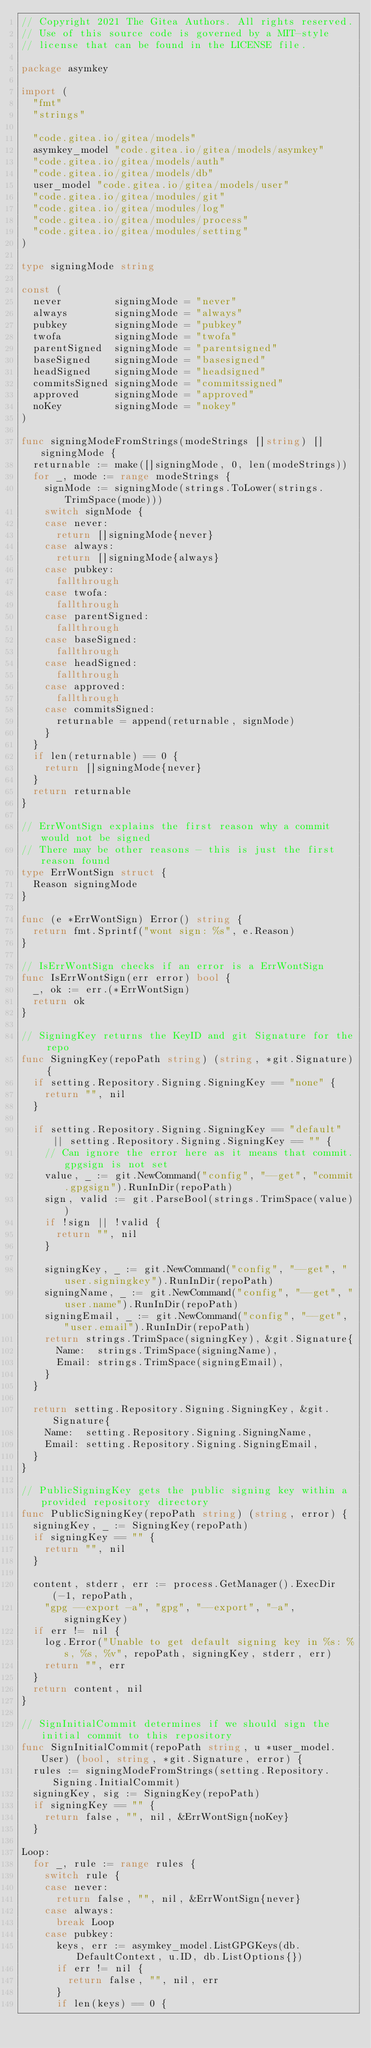<code> <loc_0><loc_0><loc_500><loc_500><_Go_>// Copyright 2021 The Gitea Authors. All rights reserved.
// Use of this source code is governed by a MIT-style
// license that can be found in the LICENSE file.

package asymkey

import (
	"fmt"
	"strings"

	"code.gitea.io/gitea/models"
	asymkey_model "code.gitea.io/gitea/models/asymkey"
	"code.gitea.io/gitea/models/auth"
	"code.gitea.io/gitea/models/db"
	user_model "code.gitea.io/gitea/models/user"
	"code.gitea.io/gitea/modules/git"
	"code.gitea.io/gitea/modules/log"
	"code.gitea.io/gitea/modules/process"
	"code.gitea.io/gitea/modules/setting"
)

type signingMode string

const (
	never         signingMode = "never"
	always        signingMode = "always"
	pubkey        signingMode = "pubkey"
	twofa         signingMode = "twofa"
	parentSigned  signingMode = "parentsigned"
	baseSigned    signingMode = "basesigned"
	headSigned    signingMode = "headsigned"
	commitsSigned signingMode = "commitssigned"
	approved      signingMode = "approved"
	noKey         signingMode = "nokey"
)

func signingModeFromStrings(modeStrings []string) []signingMode {
	returnable := make([]signingMode, 0, len(modeStrings))
	for _, mode := range modeStrings {
		signMode := signingMode(strings.ToLower(strings.TrimSpace(mode)))
		switch signMode {
		case never:
			return []signingMode{never}
		case always:
			return []signingMode{always}
		case pubkey:
			fallthrough
		case twofa:
			fallthrough
		case parentSigned:
			fallthrough
		case baseSigned:
			fallthrough
		case headSigned:
			fallthrough
		case approved:
			fallthrough
		case commitsSigned:
			returnable = append(returnable, signMode)
		}
	}
	if len(returnable) == 0 {
		return []signingMode{never}
	}
	return returnable
}

// ErrWontSign explains the first reason why a commit would not be signed
// There may be other reasons - this is just the first reason found
type ErrWontSign struct {
	Reason signingMode
}

func (e *ErrWontSign) Error() string {
	return fmt.Sprintf("wont sign: %s", e.Reason)
}

// IsErrWontSign checks if an error is a ErrWontSign
func IsErrWontSign(err error) bool {
	_, ok := err.(*ErrWontSign)
	return ok
}

// SigningKey returns the KeyID and git Signature for the repo
func SigningKey(repoPath string) (string, *git.Signature) {
	if setting.Repository.Signing.SigningKey == "none" {
		return "", nil
	}

	if setting.Repository.Signing.SigningKey == "default" || setting.Repository.Signing.SigningKey == "" {
		// Can ignore the error here as it means that commit.gpgsign is not set
		value, _ := git.NewCommand("config", "--get", "commit.gpgsign").RunInDir(repoPath)
		sign, valid := git.ParseBool(strings.TrimSpace(value))
		if !sign || !valid {
			return "", nil
		}

		signingKey, _ := git.NewCommand("config", "--get", "user.signingkey").RunInDir(repoPath)
		signingName, _ := git.NewCommand("config", "--get", "user.name").RunInDir(repoPath)
		signingEmail, _ := git.NewCommand("config", "--get", "user.email").RunInDir(repoPath)
		return strings.TrimSpace(signingKey), &git.Signature{
			Name:  strings.TrimSpace(signingName),
			Email: strings.TrimSpace(signingEmail),
		}
	}

	return setting.Repository.Signing.SigningKey, &git.Signature{
		Name:  setting.Repository.Signing.SigningName,
		Email: setting.Repository.Signing.SigningEmail,
	}
}

// PublicSigningKey gets the public signing key within a provided repository directory
func PublicSigningKey(repoPath string) (string, error) {
	signingKey, _ := SigningKey(repoPath)
	if signingKey == "" {
		return "", nil
	}

	content, stderr, err := process.GetManager().ExecDir(-1, repoPath,
		"gpg --export -a", "gpg", "--export", "-a", signingKey)
	if err != nil {
		log.Error("Unable to get default signing key in %s: %s, %s, %v", repoPath, signingKey, stderr, err)
		return "", err
	}
	return content, nil
}

// SignInitialCommit determines if we should sign the initial commit to this repository
func SignInitialCommit(repoPath string, u *user_model.User) (bool, string, *git.Signature, error) {
	rules := signingModeFromStrings(setting.Repository.Signing.InitialCommit)
	signingKey, sig := SigningKey(repoPath)
	if signingKey == "" {
		return false, "", nil, &ErrWontSign{noKey}
	}

Loop:
	for _, rule := range rules {
		switch rule {
		case never:
			return false, "", nil, &ErrWontSign{never}
		case always:
			break Loop
		case pubkey:
			keys, err := asymkey_model.ListGPGKeys(db.DefaultContext, u.ID, db.ListOptions{})
			if err != nil {
				return false, "", nil, err
			}
			if len(keys) == 0 {</code> 